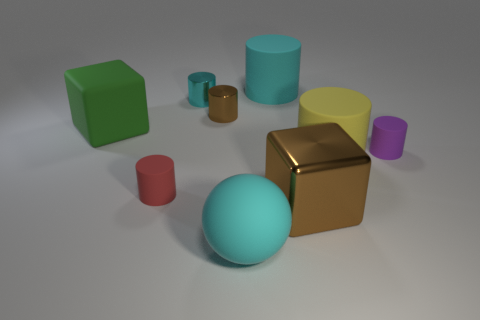What shape is the red thing that is the same size as the purple matte object? The red object that shares its size with the purple matte object is a cylinder. This shape is characterized by its circular base and the way it extends upwards in a smooth, straight line, much like a can or a tube. 